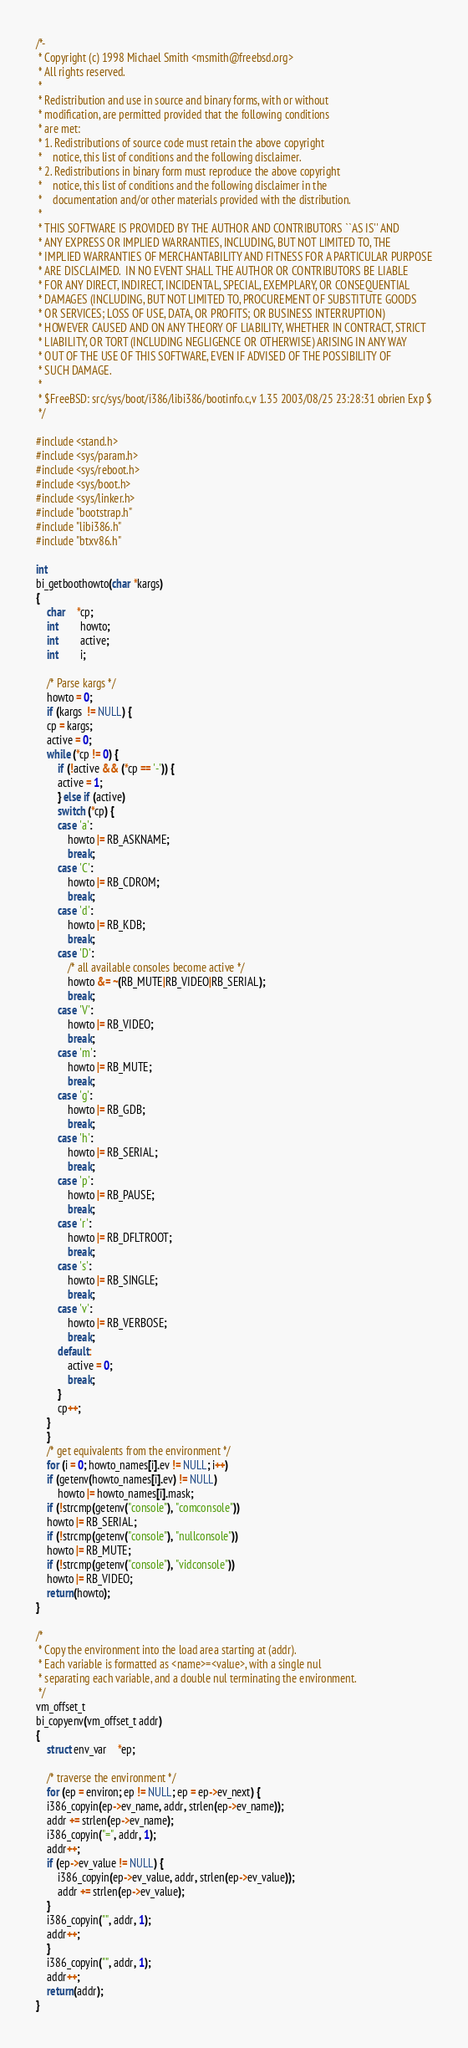Convert code to text. <code><loc_0><loc_0><loc_500><loc_500><_C_>/*-
 * Copyright (c) 1998 Michael Smith <msmith@freebsd.org>
 * All rights reserved.
 *
 * Redistribution and use in source and binary forms, with or without
 * modification, are permitted provided that the following conditions
 * are met:
 * 1. Redistributions of source code must retain the above copyright
 *    notice, this list of conditions and the following disclaimer.
 * 2. Redistributions in binary form must reproduce the above copyright
 *    notice, this list of conditions and the following disclaimer in the
 *    documentation and/or other materials provided with the distribution.
 *
 * THIS SOFTWARE IS PROVIDED BY THE AUTHOR AND CONTRIBUTORS ``AS IS'' AND
 * ANY EXPRESS OR IMPLIED WARRANTIES, INCLUDING, BUT NOT LIMITED TO, THE
 * IMPLIED WARRANTIES OF MERCHANTABILITY AND FITNESS FOR A PARTICULAR PURPOSE
 * ARE DISCLAIMED.  IN NO EVENT SHALL THE AUTHOR OR CONTRIBUTORS BE LIABLE
 * FOR ANY DIRECT, INDIRECT, INCIDENTAL, SPECIAL, EXEMPLARY, OR CONSEQUENTIAL
 * DAMAGES (INCLUDING, BUT NOT LIMITED TO, PROCUREMENT OF SUBSTITUTE GOODS
 * OR SERVICES; LOSS OF USE, DATA, OR PROFITS; OR BUSINESS INTERRUPTION)
 * HOWEVER CAUSED AND ON ANY THEORY OF LIABILITY, WHETHER IN CONTRACT, STRICT
 * LIABILITY, OR TORT (INCLUDING NEGLIGENCE OR OTHERWISE) ARISING IN ANY WAY
 * OUT OF THE USE OF THIS SOFTWARE, EVEN IF ADVISED OF THE POSSIBILITY OF
 * SUCH DAMAGE.
 *
 * $FreeBSD: src/sys/boot/i386/libi386/bootinfo.c,v 1.35 2003/08/25 23:28:31 obrien Exp $
 */

#include <stand.h>
#include <sys/param.h>
#include <sys/reboot.h>
#include <sys/boot.h>
#include <sys/linker.h>
#include "bootstrap.h"
#include "libi386.h"
#include "btxv86.h"

int
bi_getboothowto(char *kargs)
{
    char	*cp;
    int		howto;
    int		active;
    int		i;
    
    /* Parse kargs */
    howto = 0;
    if (kargs  != NULL) {
	cp = kargs;
	active = 0;
	while (*cp != 0) {
	    if (!active && (*cp == '-')) {
		active = 1;
	    } else if (active)
		switch (*cp) {
		case 'a':
		    howto |= RB_ASKNAME;
		    break;
		case 'C':
		    howto |= RB_CDROM;
		    break;
		case 'd':
		    howto |= RB_KDB;
		    break;
		case 'D':
		    /* all available consoles become active */
		    howto &= ~(RB_MUTE|RB_VIDEO|RB_SERIAL);
		    break;
		case 'V':
		    howto |= RB_VIDEO;
		    break;
		case 'm':
		    howto |= RB_MUTE;
		    break;
		case 'g':
		    howto |= RB_GDB;
		    break;
		case 'h':
		    howto |= RB_SERIAL;
		    break;
		case 'p':
		    howto |= RB_PAUSE;
		    break;
		case 'r':
		    howto |= RB_DFLTROOT;
		    break;
		case 's':
		    howto |= RB_SINGLE;
		    break;
		case 'v':
		    howto |= RB_VERBOSE;
		    break;
		default:
		    active = 0;
		    break;
		}
	    cp++;
	}
    }
    /* get equivalents from the environment */
    for (i = 0; howto_names[i].ev != NULL; i++)
	if (getenv(howto_names[i].ev) != NULL)
	    howto |= howto_names[i].mask;
    if (!strcmp(getenv("console"), "comconsole"))
	howto |= RB_SERIAL;
    if (!strcmp(getenv("console"), "nullconsole"))
	howto |= RB_MUTE;
    if (!strcmp(getenv("console"), "vidconsole"))
	howto |= RB_VIDEO;
    return(howto);
}

/*
 * Copy the environment into the load area starting at (addr).
 * Each variable is formatted as <name>=<value>, with a single nul
 * separating each variable, and a double nul terminating the environment.
 */
vm_offset_t
bi_copyenv(vm_offset_t addr)
{
    struct env_var	*ep;
    
    /* traverse the environment */
    for (ep = environ; ep != NULL; ep = ep->ev_next) {
	i386_copyin(ep->ev_name, addr, strlen(ep->ev_name));
	addr += strlen(ep->ev_name);
	i386_copyin("=", addr, 1);
	addr++;
	if (ep->ev_value != NULL) {
	    i386_copyin(ep->ev_value, addr, strlen(ep->ev_value));
	    addr += strlen(ep->ev_value);
	}
	i386_copyin("", addr, 1);
	addr++;
    }
    i386_copyin("", addr, 1);
    addr++;
    return(addr);
}
</code> 